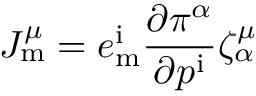Convert formula to latex. <formula><loc_0><loc_0><loc_500><loc_500>J _ { m } ^ { \mu } = e _ { m } ^ { i } { \frac { \partial \pi ^ { \alpha } } { \partial p ^ { i } } } \zeta _ { \alpha } ^ { \mu }</formula> 